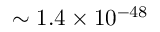<formula> <loc_0><loc_0><loc_500><loc_500>\sim 1 . 4 \times 1 0 ^ { - 4 8 }</formula> 